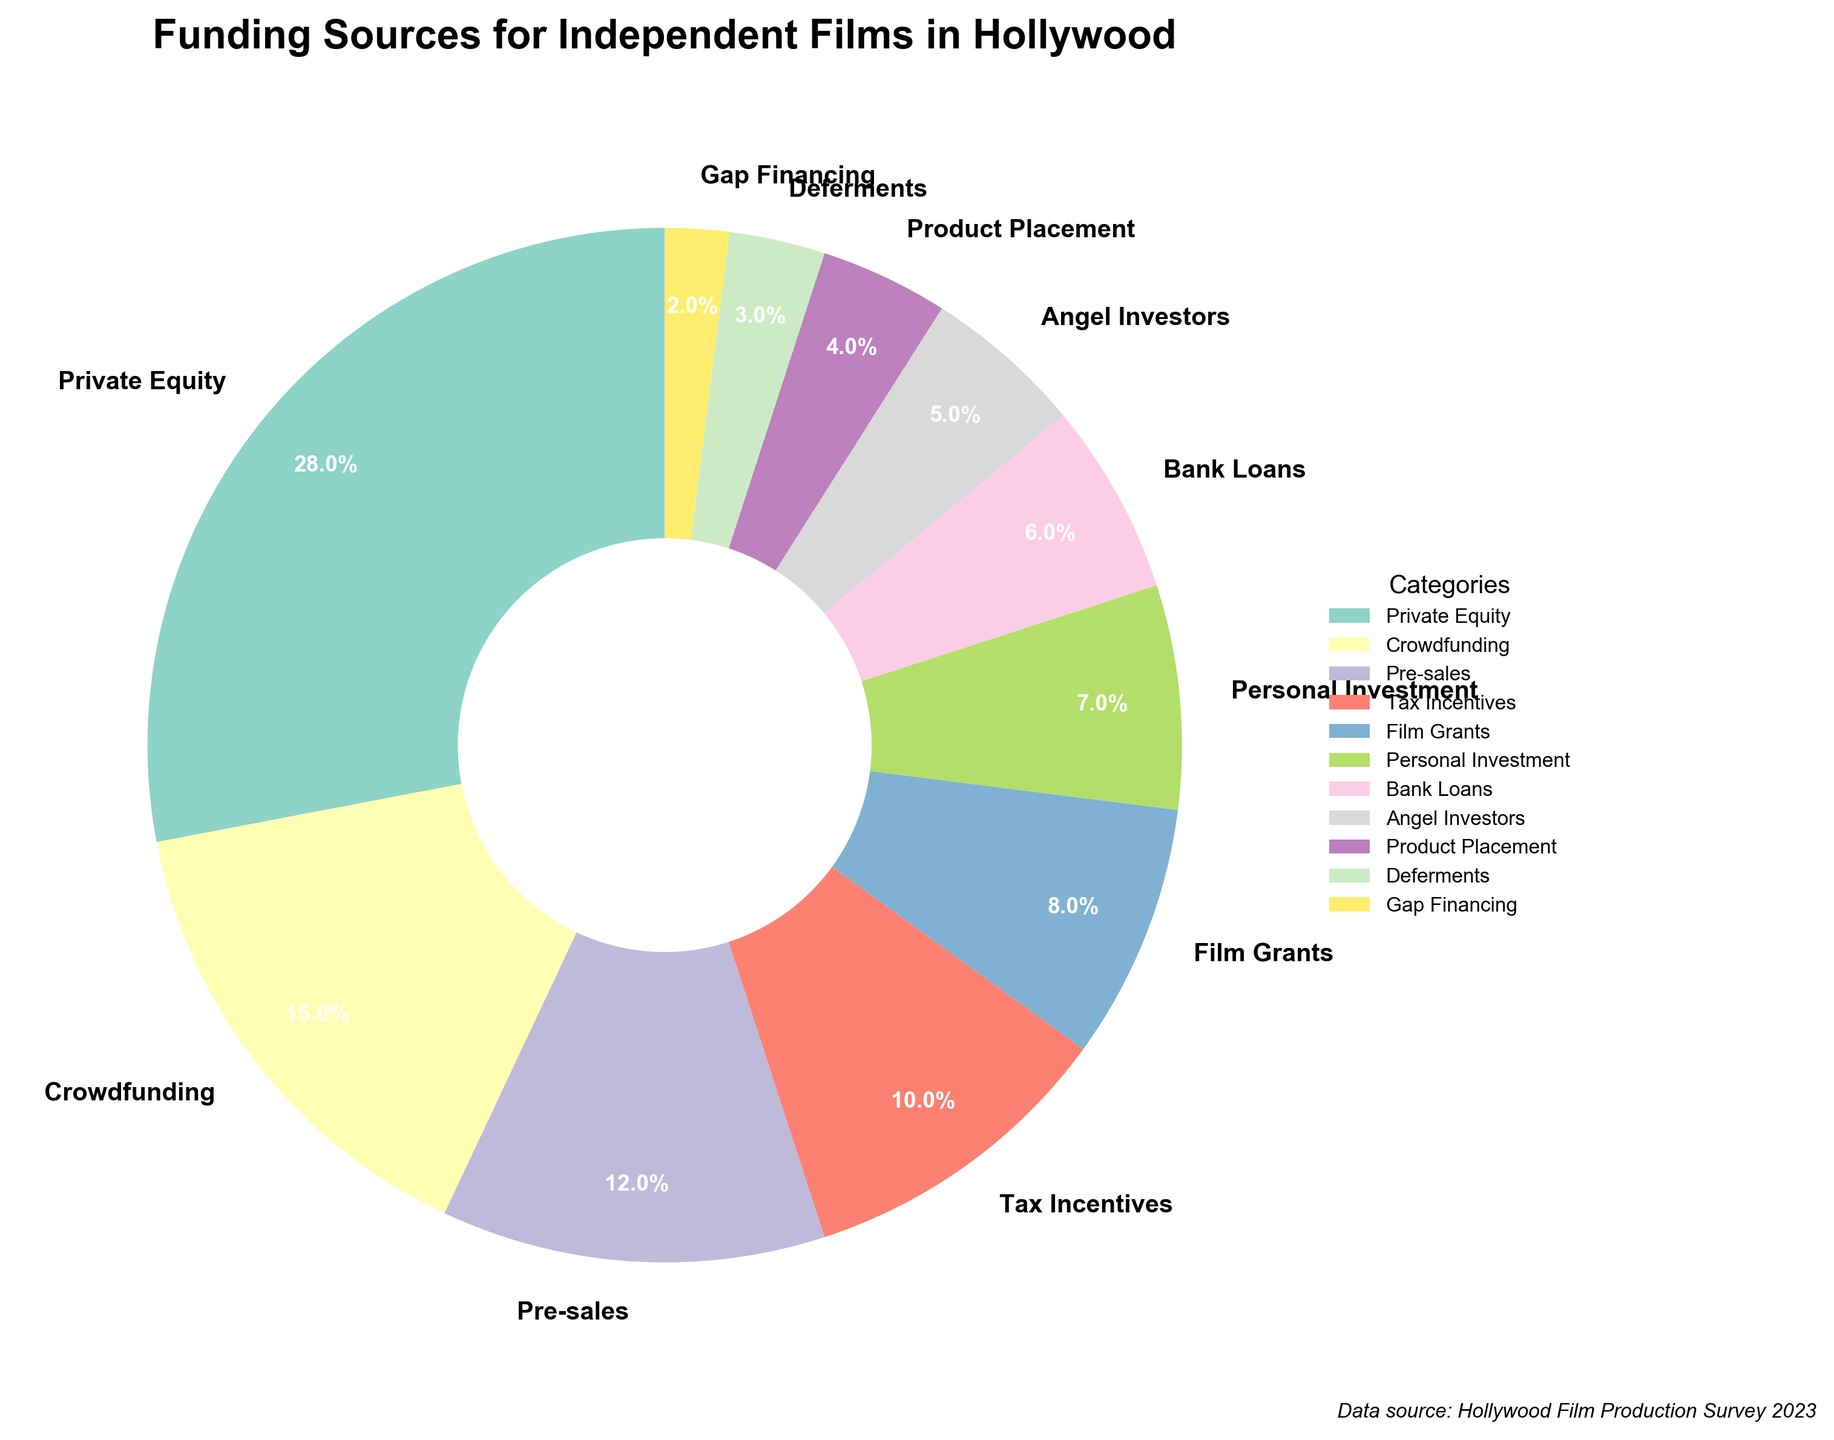What is the largest source of funding for independent films in Hollywood? The pie chart shows the largest slice represents Private Equity.
Answer: Private Equity What is the combined percentage of funding from Tax Incentives, Film Grants, and Bank Loans? Adding the percentages: Tax Incentives (10%) + Film Grants (8%) + Bank Loans (6%) = 24%.
Answer: 24% Which funding source contributes less than Product Placement? Looking at the percentages smaller than Product Placement (4%): Deferments (3%) and Gap Financing (2%) are smaller.
Answer: Deferments, Gap Financing How much more does Private Equity contribute compared to Crowdfunding? Subtract Crowdfunding's percentage (15%) from Private Equity's percentage (28%), which gives 28% - 15% = 13%.
Answer: 13% What is the visual difference between the wedges representing Angel Investors and Pre-sales? Angel Investors have a smaller wedge and occupy 5%, while Pre-sales occupy 12%, making the Pre-sales wedge notably larger.
Answer: Pre-sales wedge is larger than Angel Investors If you combine the percentages of Pre-sales and Crowdfunding, do they surpass Private Equity? Adding Pre-sales (12%) and Crowdfunding (15%) equals 27%, which is still less than Private Equity's 28%.
Answer: No Which category is represented by the second smallest wedge, and what percentage does it hold? The smallest wedge is Gap Financing (2%), so the second smallest is Deferments at 3%.
Answer: Deferments, 3% How much combined contribution do Personal Investment and Angel Investors make? Adding Personal Investment (7%) and Angel Investors (5%), we get 7% + 5% = 12%.
Answer: 12% Which funding source is just below Private Equity in terms of percentage? Crowdfunding is the second largest funding source after Private Equity according to the chart.
Answer: Crowdfunding What total percentage do sources with less than 10% contribution each make? Adding percentages of Pre-sales (12%), Film Grants (8%), Personal Investment (7%), Bank Loans (6%), Angel Investors (5%), Product Placement (4%), Deferments (3%), Gap Financing (2%). Skip Pre-sales but sum others: 8% + 7% + 6% + 5% + 4% + 3% + 2% = 35%.
Answer: 35% 